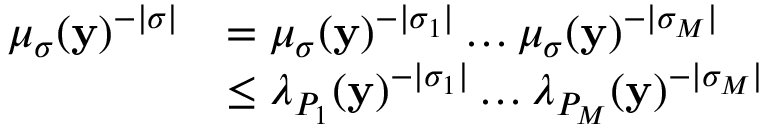Convert formula to latex. <formula><loc_0><loc_0><loc_500><loc_500>\begin{array} { r l } { \mu _ { \sigma } ( y ) ^ { - | \sigma | } } & { = \mu _ { \sigma } ( y ) ^ { - | \sigma _ { 1 } | } \dots \mu _ { \sigma } ( y ) ^ { - | \sigma _ { M } | } } \\ & { \leq \lambda _ { P _ { 1 } } ( y ) ^ { - | \sigma _ { 1 } | } \dots \lambda _ { P _ { M } } ( y ) ^ { - | \sigma _ { M } | } } \end{array}</formula> 